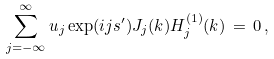Convert formula to latex. <formula><loc_0><loc_0><loc_500><loc_500>\sum _ { j = - \infty } ^ { \infty } u _ { j } \exp ( i j s ^ { \prime } ) J _ { j } ( k ) H _ { j } ^ { ( 1 ) } ( k ) \, = \, 0 \, ,</formula> 